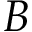<formula> <loc_0><loc_0><loc_500><loc_500>B</formula> 